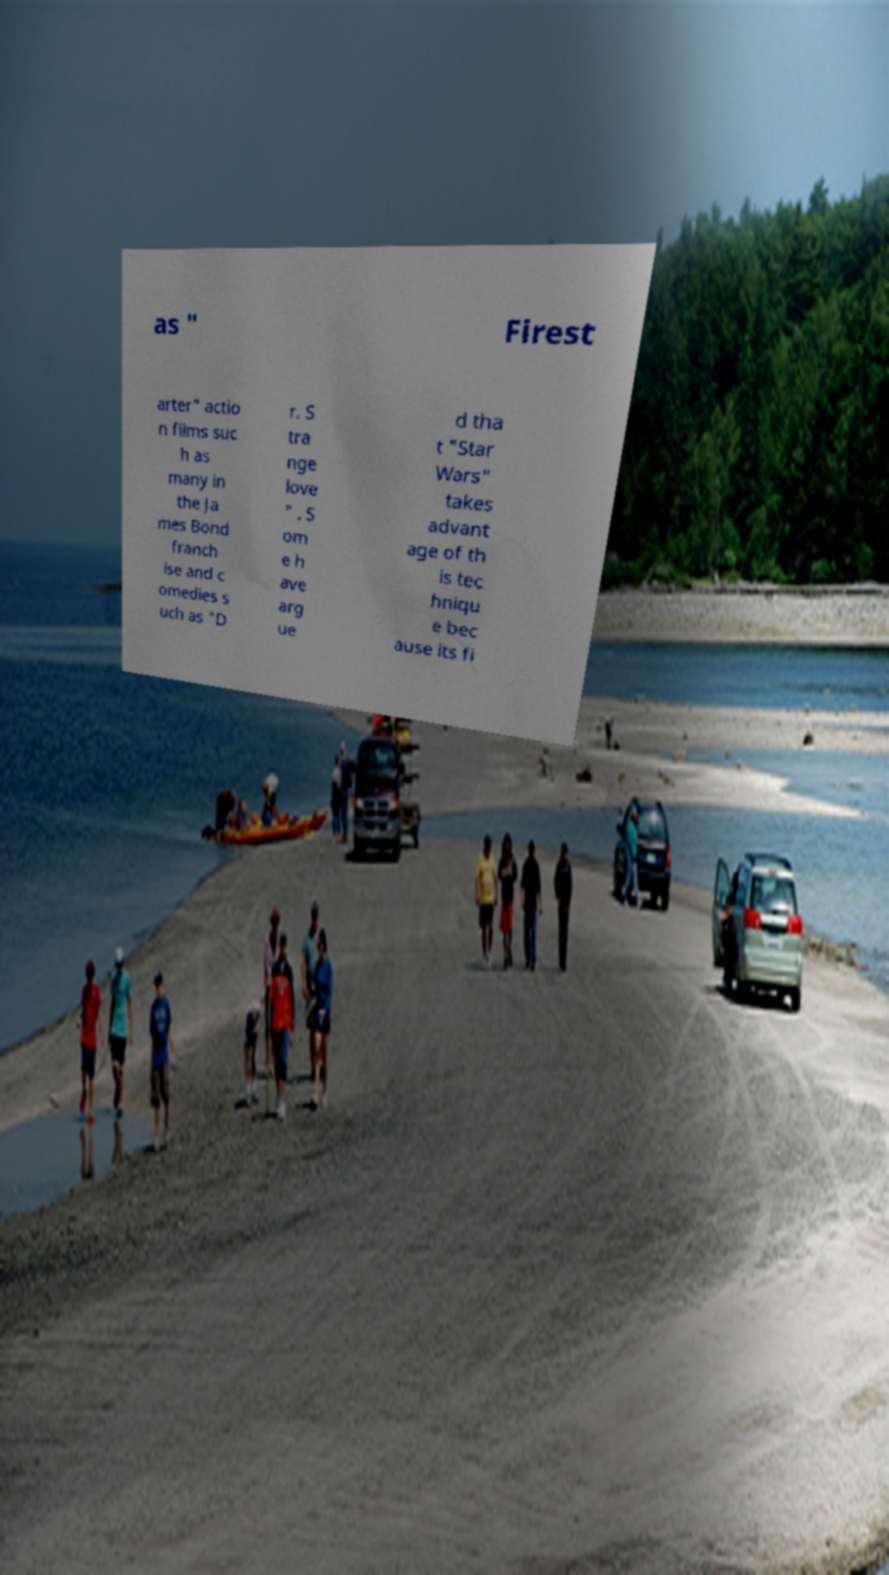I need the written content from this picture converted into text. Can you do that? as " Firest arter" actio n films suc h as many in the Ja mes Bond franch ise and c omedies s uch as "D r. S tra nge love " . S om e h ave arg ue d tha t "Star Wars" takes advant age of th is tec hniqu e bec ause its fi 